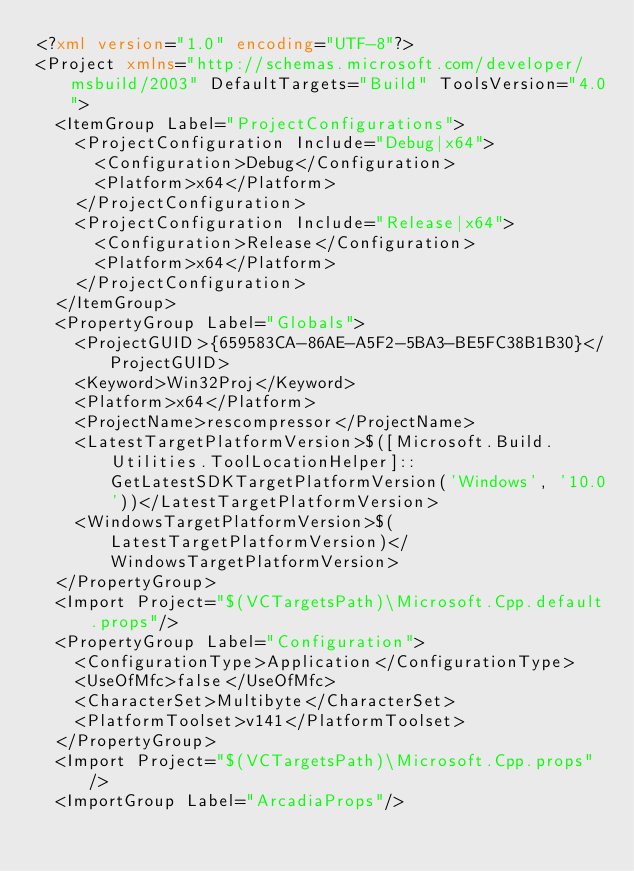Convert code to text. <code><loc_0><loc_0><loc_500><loc_500><_XML_><?xml version="1.0" encoding="UTF-8"?>
<Project xmlns="http://schemas.microsoft.com/developer/msbuild/2003" DefaultTargets="Build" ToolsVersion="4.0">
  <ItemGroup Label="ProjectConfigurations">
    <ProjectConfiguration Include="Debug|x64">
      <Configuration>Debug</Configuration>
      <Platform>x64</Platform>
    </ProjectConfiguration>
    <ProjectConfiguration Include="Release|x64">
      <Configuration>Release</Configuration>
      <Platform>x64</Platform>
    </ProjectConfiguration>
  </ItemGroup>
  <PropertyGroup Label="Globals">
    <ProjectGUID>{659583CA-86AE-A5F2-5BA3-BE5FC38B1B30}</ProjectGUID>
    <Keyword>Win32Proj</Keyword>
    <Platform>x64</Platform>
    <ProjectName>rescompressor</ProjectName>
    <LatestTargetPlatformVersion>$([Microsoft.Build.Utilities.ToolLocationHelper]::GetLatestSDKTargetPlatformVersion('Windows', '10.0'))</LatestTargetPlatformVersion>
    <WindowsTargetPlatformVersion>$(LatestTargetPlatformVersion)</WindowsTargetPlatformVersion>
  </PropertyGroup>
  <Import Project="$(VCTargetsPath)\Microsoft.Cpp.default.props"/>
  <PropertyGroup Label="Configuration">
    <ConfigurationType>Application</ConfigurationType>
    <UseOfMfc>false</UseOfMfc>
    <CharacterSet>Multibyte</CharacterSet>
    <PlatformToolset>v141</PlatformToolset>
  </PropertyGroup>
  <Import Project="$(VCTargetsPath)\Microsoft.Cpp.props"/>
  <ImportGroup Label="ArcadiaProps"/></code> 